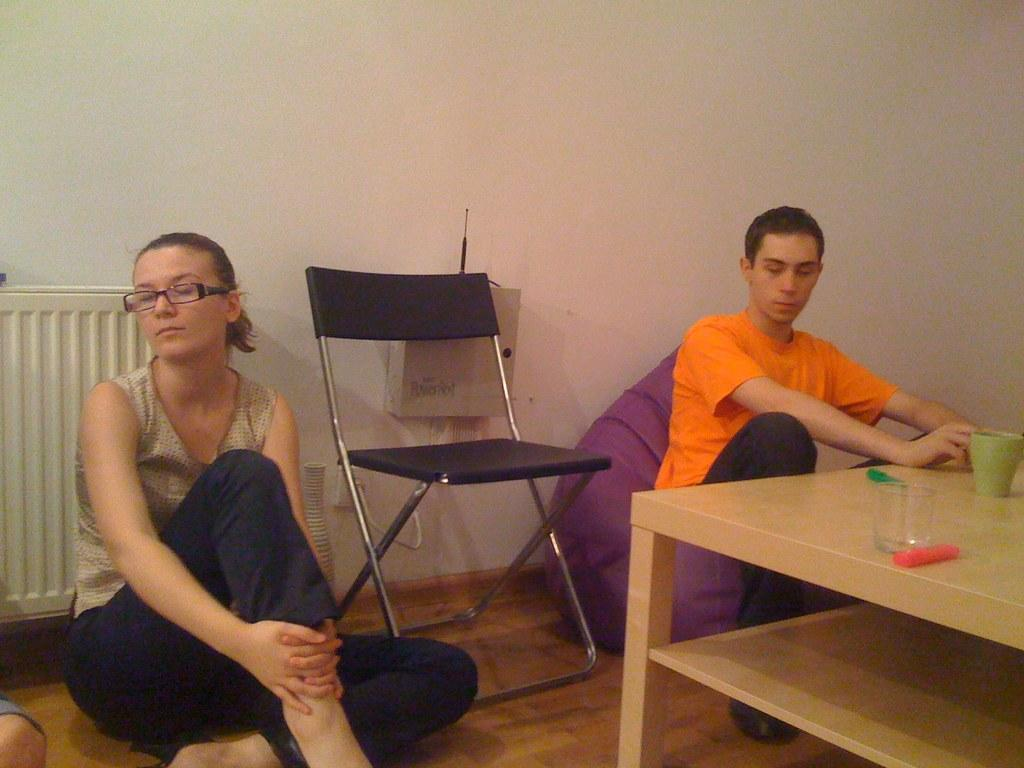What is the woman doing in the image? The woman is sitting on the ground in the image. What is the man doing in the image? The man is sitting on a chair in the image. What can be seen on the table in the image? There is a glass, a cup, and an object on the table in the image. How many chairs are visible in the image? There is one chair visible in the image. What religion is being practiced in the image? There is no indication of any religious practice in the image. What is the value of the object on the table in the image? The value of the object on the table cannot be determined from the image alone. 